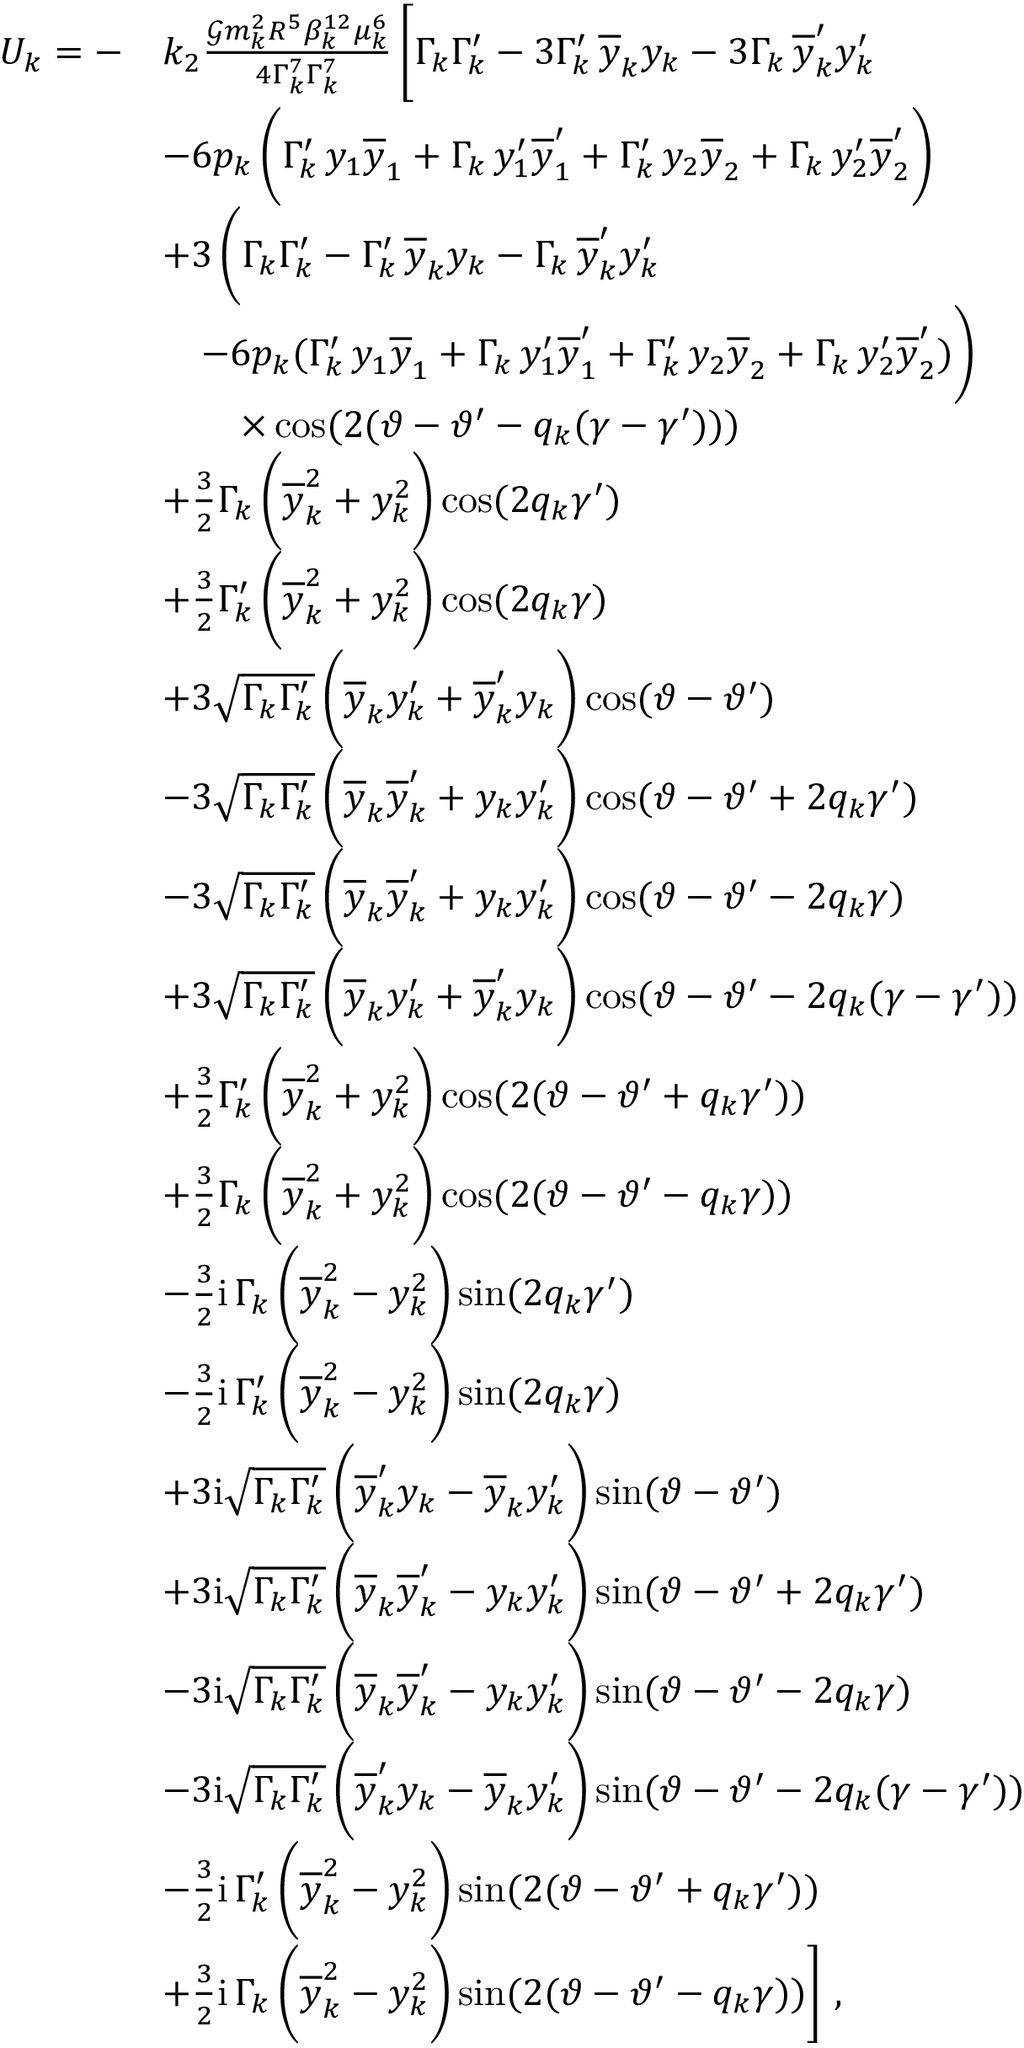Convert formula to latex. <formula><loc_0><loc_0><loc_500><loc_500>\begin{array} { r l } { U _ { k } = - } & { k _ { 2 } \frac { \mathcal { G } m _ { k } ^ { 2 } R ^ { 5 } \beta _ { k } ^ { 1 2 } \mu _ { k } ^ { 6 } } { 4 \Gamma _ { k } ^ { 7 } \Gamma _ { k } ^ { 7 } } \, \left [ \Gamma _ { k } \Gamma _ { k } ^ { \prime } - 3 \Gamma _ { k } ^ { \prime } \, \overline { y } _ { k } y _ { k } - 3 \Gamma _ { k } \, \overline { y } _ { k } ^ { \prime } y _ { k } ^ { \prime } } \\ & { - 6 p _ { k } \, \left ( \Gamma _ { k } ^ { \prime } \, y _ { 1 } \overline { y } _ { 1 } + \Gamma _ { k } \, y _ { 1 } ^ { \prime } \overline { y } _ { 1 } ^ { \prime } + \Gamma _ { k } ^ { \prime } \, y _ { 2 } \overline { y } _ { 2 } + \Gamma _ { k } \, y _ { 2 } ^ { \prime } \overline { y } _ { 2 } ^ { \prime } \right ) } \\ & { + 3 \, \left ( \Gamma _ { k } \Gamma _ { k } ^ { \prime } - \Gamma _ { k } ^ { \prime } \, \overline { y } _ { k } y _ { k } - \Gamma _ { k } \, \overline { y } _ { k } ^ { \prime } y _ { k } ^ { \prime } } \\ & { \quad - 6 p _ { k } ( \Gamma _ { k } ^ { \prime } \, y _ { 1 } \overline { y } _ { 1 } + \Gamma _ { k } \, y _ { 1 } ^ { \prime } \overline { y } _ { 1 } ^ { \prime } + \Gamma _ { k } ^ { \prime } \, y _ { 2 } \overline { y } _ { 2 } + \Gamma _ { k } \, y _ { 2 } ^ { \prime } \overline { y } _ { 2 } ^ { \prime } ) \right ) } \\ & { \quad \times \cos ( 2 ( \vartheta - \vartheta ^ { \prime } - q _ { k } ( \gamma - \gamma ^ { \prime } ) ) ) } \\ & { + \frac { 3 } { 2 } \Gamma _ { k } \, \left ( \overline { y } _ { k } ^ { 2 } + y _ { k } ^ { 2 } \right ) \cos ( 2 q _ { k } \gamma ^ { \prime } ) } \\ & { + \frac { 3 } { 2 } \Gamma _ { k } ^ { \prime } \, \left ( \overline { y } _ { k } ^ { 2 } + y _ { k } ^ { 2 } \right ) \cos ( 2 q _ { k } \gamma ) } \\ & { + 3 \sqrt { \Gamma _ { k } \Gamma _ { k } ^ { \prime } } \, \left ( \overline { y } _ { k } y _ { k } ^ { \prime } + \overline { y } _ { k } ^ { \prime } y _ { k } \right ) \cos ( \vartheta - \vartheta ^ { \prime } ) } \\ & { - 3 \sqrt { \Gamma _ { k } \Gamma _ { k } ^ { \prime } } \, \left ( \overline { y } _ { k } \overline { y } _ { k } ^ { \prime } + y _ { k } y _ { k } ^ { \prime } \right ) \cos ( \vartheta - \vartheta ^ { \prime } + 2 q _ { k } \gamma ^ { \prime } ) } \\ & { - 3 \sqrt { \Gamma _ { k } \Gamma _ { k } ^ { \prime } } \, \left ( \overline { y } _ { k } \overline { y } _ { k } ^ { \prime } + y _ { k } y _ { k } ^ { \prime } \right ) \cos ( \vartheta - \vartheta ^ { \prime } - 2 q _ { k } \gamma ) } \\ & { + 3 \sqrt { \Gamma _ { k } \Gamma _ { k } ^ { \prime } } \, \left ( \overline { y } _ { k } y _ { k } ^ { \prime } + \overline { y } _ { k } ^ { \prime } y _ { k } \right ) \cos ( \vartheta - \vartheta ^ { \prime } - 2 q _ { k } ( \gamma - \gamma ^ { \prime } ) ) } \\ & { + \frac { 3 } { 2 } \Gamma _ { k } ^ { \prime } \, \left ( \overline { y } _ { k } ^ { 2 } + y _ { k } ^ { 2 } \right ) \cos ( 2 ( \vartheta - \vartheta ^ { \prime } + q _ { k } \gamma ^ { \prime } ) ) } \\ & { + \frac { 3 } { 2 } \Gamma _ { k } \, \left ( \overline { y } _ { k } ^ { 2 } + y _ { k } ^ { 2 } \right ) \cos ( 2 ( \vartheta - \vartheta ^ { \prime } - q _ { k } \gamma ) ) } \\ & { - \frac { 3 } { 2 } i \, \Gamma _ { k } \, \left ( \overline { y } _ { k } ^ { 2 } - y _ { k } ^ { 2 } \right ) \sin ( 2 q _ { k } \gamma ^ { \prime } ) } \\ & { - \frac { 3 } { 2 } i \, \Gamma _ { k } ^ { \prime } \, \left ( \overline { y } _ { k } ^ { 2 } - y _ { k } ^ { 2 } \right ) \sin ( 2 q _ { k } \gamma ) } \\ & { + 3 i \sqrt { \Gamma _ { k } \Gamma _ { k } ^ { \prime } } \, \left ( \overline { y } _ { k } ^ { \prime } y _ { k } - \overline { y } _ { k } y _ { k } ^ { \prime } \right ) \sin ( \vartheta - \vartheta ^ { \prime } ) } \\ & { + 3 i \sqrt { \Gamma _ { k } \Gamma _ { k } ^ { \prime } } \, \left ( \overline { y } _ { k } \overline { y } _ { k } ^ { \prime } - y _ { k } y _ { k } ^ { \prime } \right ) \sin ( \vartheta - \vartheta ^ { \prime } + 2 q _ { k } \gamma ^ { \prime } ) } \\ & { - 3 i \sqrt { \Gamma _ { k } \Gamma _ { k } ^ { \prime } } \, \left ( \overline { y } _ { k } \overline { y } _ { k } ^ { \prime } - y _ { k } y _ { k } ^ { \prime } \right ) \sin ( \vartheta - \vartheta ^ { \prime } - 2 q _ { k } \gamma ) } \\ & { - 3 i \sqrt { \Gamma _ { k } \Gamma _ { k } ^ { \prime } } \, \left ( \overline { y } _ { k } ^ { \prime } y _ { k } - \overline { y } _ { k } y _ { k } ^ { \prime } \right ) \sin ( \vartheta - \vartheta ^ { \prime } - 2 q _ { k } ( \gamma - \gamma ^ { \prime } ) ) } \\ & { - \frac { 3 } { 2 } i \, \Gamma _ { k } ^ { \prime } \, \left ( \overline { y } _ { k } ^ { 2 } - y _ { k } ^ { 2 } \right ) \sin ( 2 ( \vartheta - \vartheta ^ { \prime } + q _ { k } \gamma ^ { \prime } ) ) } \\ & { + \frac { 3 } { 2 } i \, \Gamma _ { k } \, \left ( \overline { y } _ { k } ^ { 2 } - y _ { k } ^ { 2 } \right ) \sin ( 2 ( \vartheta - \vartheta ^ { \prime } - q _ { k } \gamma ) ) \right ] \ , } \end{array}</formula> 